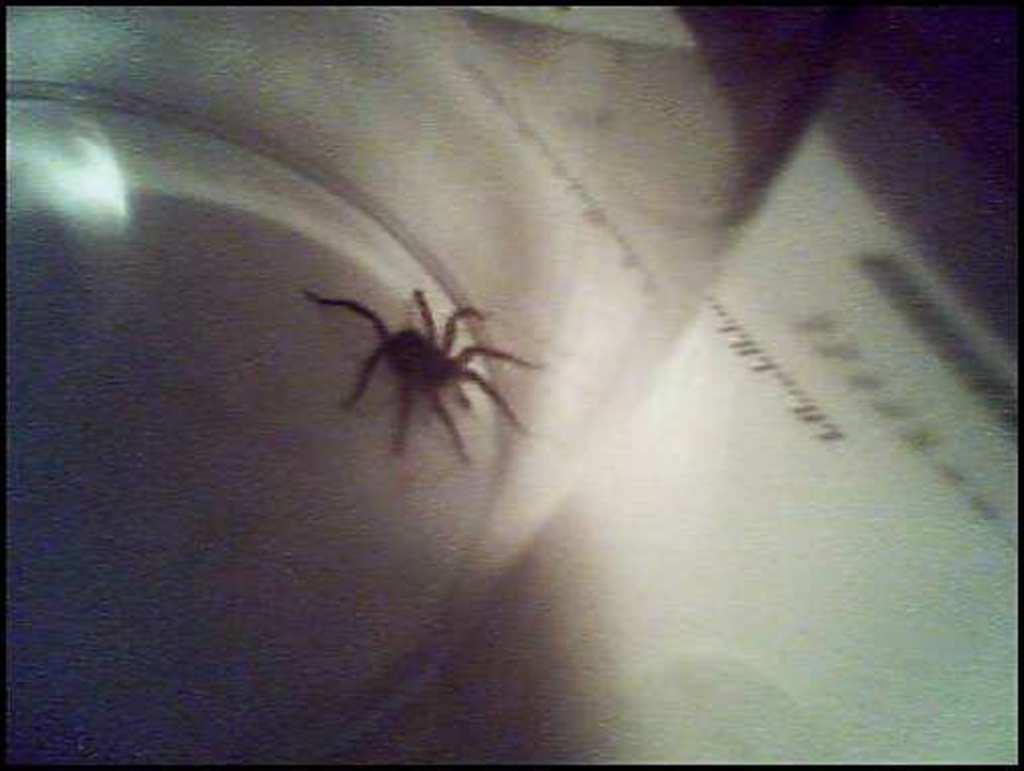What is present on the surface in the image? There is a spider on a surface in the image. What else can be seen to the right of the spider? There is text on a paper to the right of the spider. How would you describe the overall clarity of the image? The image is blurry. What type of cannon is listed in the middle of the text on the paper? There is no cannon mentioned in the text on the paper, as the provided facts do not mention a cannon or any text related to a cannon. 